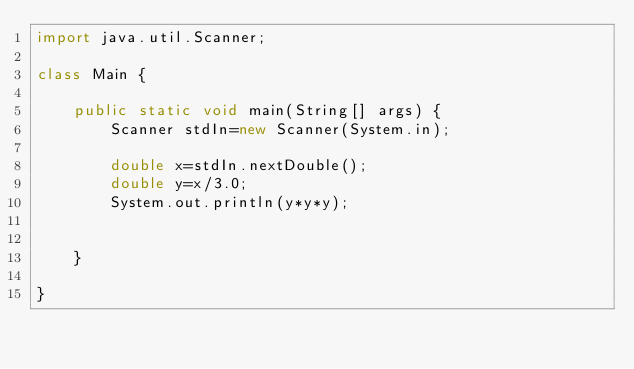Convert code to text. <code><loc_0><loc_0><loc_500><loc_500><_Java_>import java.util.Scanner;

class Main {

    public static void main(String[] args) {
        Scanner stdIn=new Scanner(System.in);

        double x=stdIn.nextDouble();
        double y=x/3.0;
        System.out.println(y*y*y);
        
        
    }

}</code> 